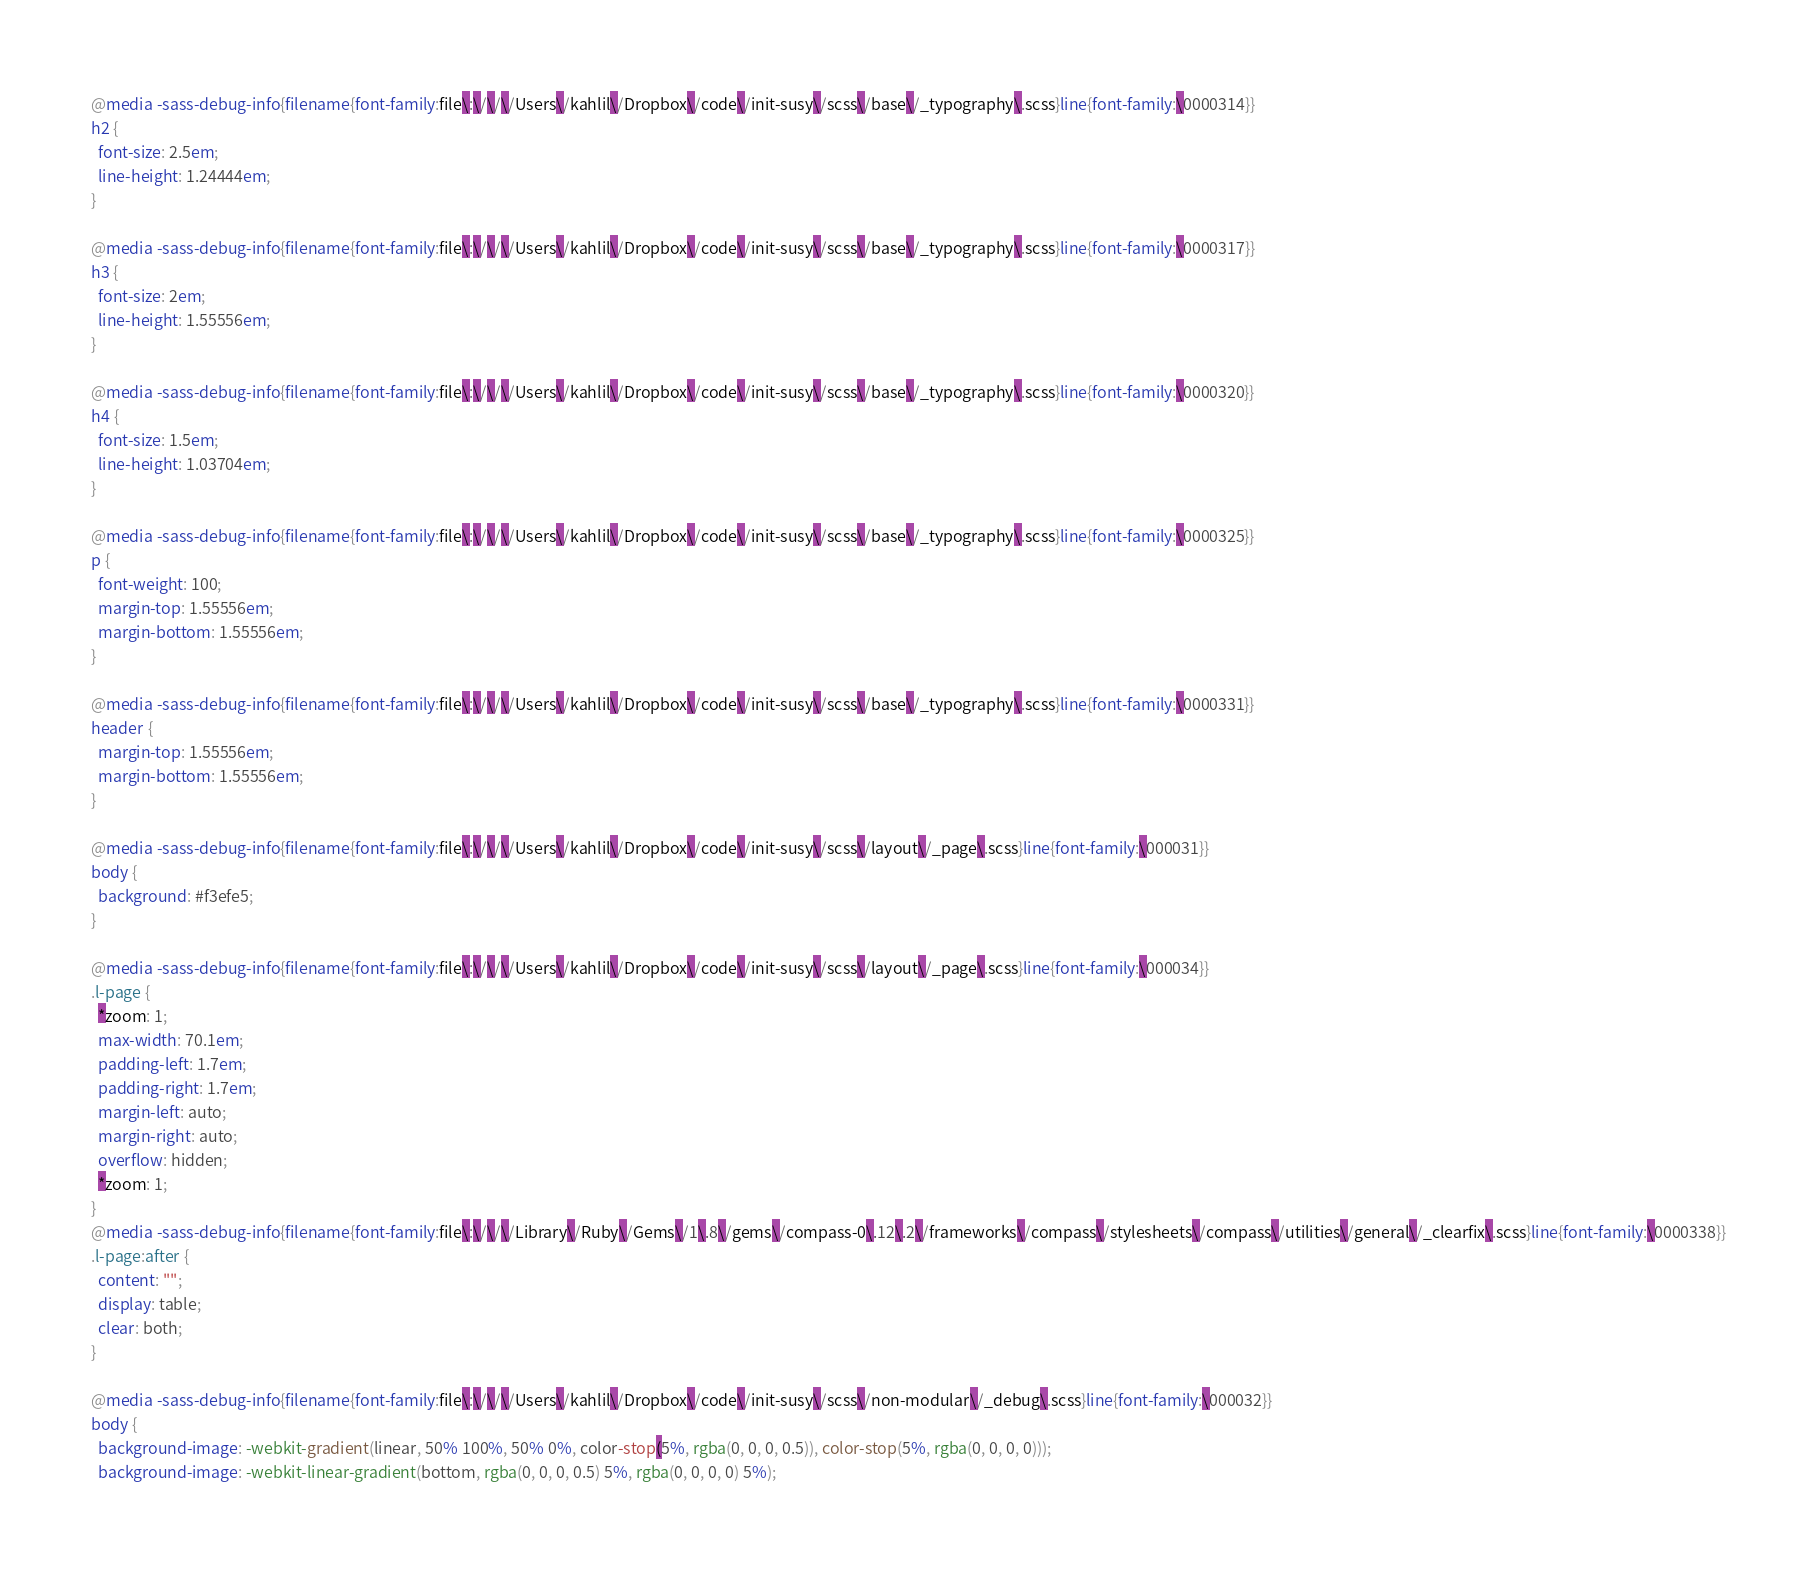<code> <loc_0><loc_0><loc_500><loc_500><_CSS_>@media -sass-debug-info{filename{font-family:file\:\/\/\/Users\/kahlil\/Dropbox\/code\/init-susy\/scss\/base\/_typography\.scss}line{font-family:\0000314}}
h2 {
  font-size: 2.5em;
  line-height: 1.24444em;
}

@media -sass-debug-info{filename{font-family:file\:\/\/\/Users\/kahlil\/Dropbox\/code\/init-susy\/scss\/base\/_typography\.scss}line{font-family:\0000317}}
h3 {
  font-size: 2em;
  line-height: 1.55556em;
}

@media -sass-debug-info{filename{font-family:file\:\/\/\/Users\/kahlil\/Dropbox\/code\/init-susy\/scss\/base\/_typography\.scss}line{font-family:\0000320}}
h4 {
  font-size: 1.5em;
  line-height: 1.03704em;
}

@media -sass-debug-info{filename{font-family:file\:\/\/\/Users\/kahlil\/Dropbox\/code\/init-susy\/scss\/base\/_typography\.scss}line{font-family:\0000325}}
p {
  font-weight: 100;
  margin-top: 1.55556em;
  margin-bottom: 1.55556em;
}

@media -sass-debug-info{filename{font-family:file\:\/\/\/Users\/kahlil\/Dropbox\/code\/init-susy\/scss\/base\/_typography\.scss}line{font-family:\0000331}}
header {
  margin-top: 1.55556em;
  margin-bottom: 1.55556em;
}

@media -sass-debug-info{filename{font-family:file\:\/\/\/Users\/kahlil\/Dropbox\/code\/init-susy\/scss\/layout\/_page\.scss}line{font-family:\000031}}
body {
  background: #f3efe5;
}

@media -sass-debug-info{filename{font-family:file\:\/\/\/Users\/kahlil\/Dropbox\/code\/init-susy\/scss\/layout\/_page\.scss}line{font-family:\000034}}
.l-page {
  *zoom: 1;
  max-width: 70.1em;
  padding-left: 1.7em;
  padding-right: 1.7em;
  margin-left: auto;
  margin-right: auto;
  overflow: hidden;
  *zoom: 1;
}
@media -sass-debug-info{filename{font-family:file\:\/\/\/Library\/Ruby\/Gems\/1\.8\/gems\/compass-0\.12\.2\/frameworks\/compass\/stylesheets\/compass\/utilities\/general\/_clearfix\.scss}line{font-family:\0000338}}
.l-page:after {
  content: "";
  display: table;
  clear: both;
}

@media -sass-debug-info{filename{font-family:file\:\/\/\/Users\/kahlil\/Dropbox\/code\/init-susy\/scss\/non-modular\/_debug\.scss}line{font-family:\000032}}
body {
  background-image: -webkit-gradient(linear, 50% 100%, 50% 0%, color-stop(5%, rgba(0, 0, 0, 0.5)), color-stop(5%, rgba(0, 0, 0, 0)));
  background-image: -webkit-linear-gradient(bottom, rgba(0, 0, 0, 0.5) 5%, rgba(0, 0, 0, 0) 5%);</code> 